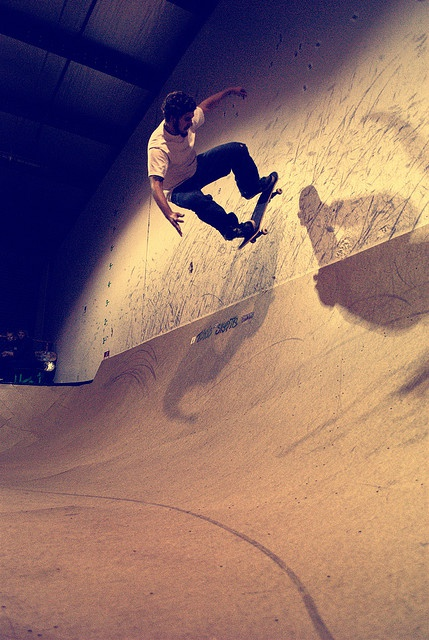Describe the objects in this image and their specific colors. I can see people in navy, purple, and khaki tones, skateboard in navy, khaki, and purple tones, people in navy, teal, and purple tones, and people in navy and purple tones in this image. 